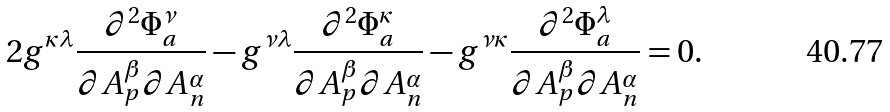Convert formula to latex. <formula><loc_0><loc_0><loc_500><loc_500>2 g ^ { \kappa \lambda } \frac { \partial ^ { 2 } \Phi _ { a } ^ { \nu } } { \partial A _ { p } ^ { \beta } \partial A _ { n } ^ { \alpha } } - g ^ { \nu \lambda } \frac { \partial ^ { 2 } \Phi _ { a } ^ { \kappa } } { \partial A _ { p } ^ { \beta } \partial A _ { n } ^ { \alpha } } - g ^ { \nu \kappa } \frac { \partial ^ { 2 } \Phi _ { a } ^ { \lambda } } { \partial A _ { p } ^ { \beta } \partial A _ { n } ^ { \alpha } } = 0 .</formula> 